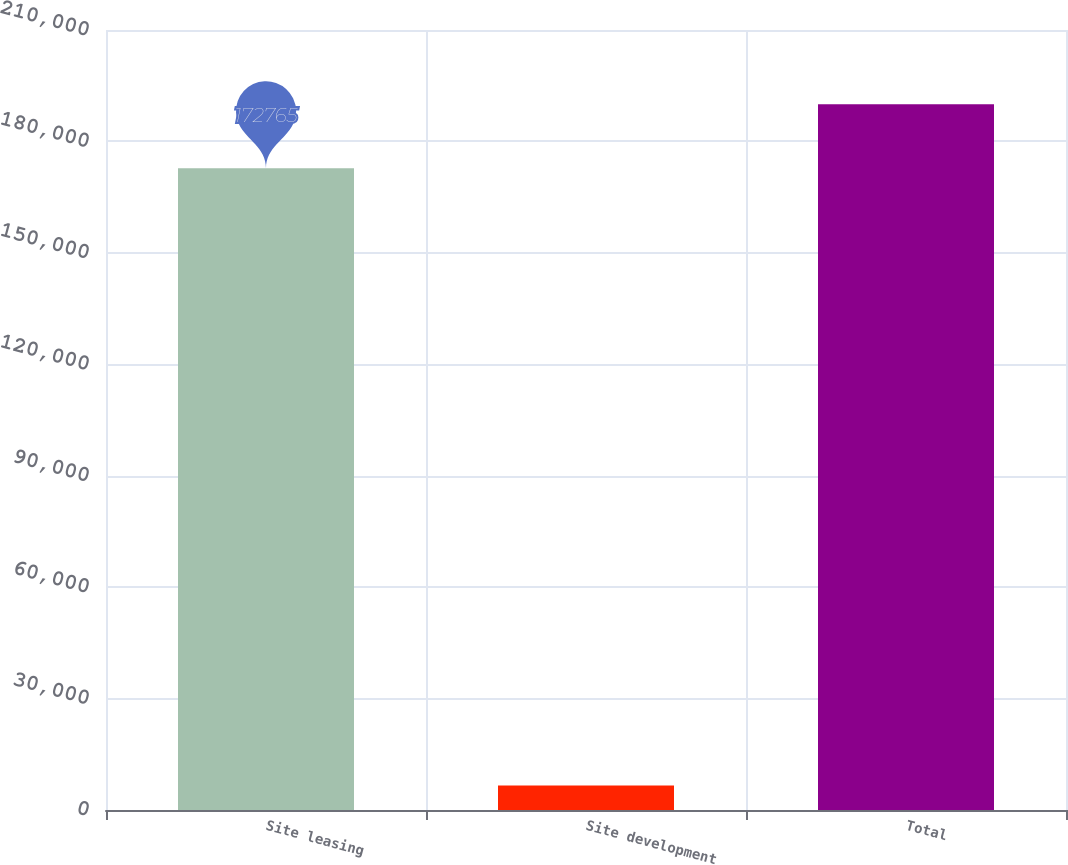<chart> <loc_0><loc_0><loc_500><loc_500><bar_chart><fcel>Site leasing<fcel>Site development<fcel>Total<nl><fcel>172765<fcel>6563<fcel>190042<nl></chart> 